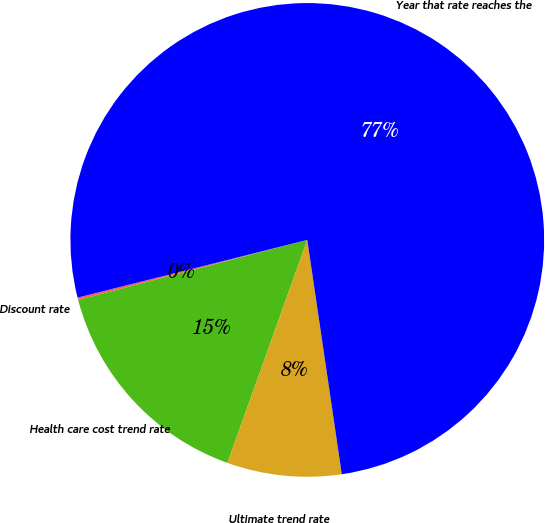Convert chart. <chart><loc_0><loc_0><loc_500><loc_500><pie_chart><fcel>Discount rate<fcel>Health care cost trend rate<fcel>Ultimate trend rate<fcel>Year that rate reaches the<nl><fcel>0.16%<fcel>15.45%<fcel>7.8%<fcel>76.59%<nl></chart> 